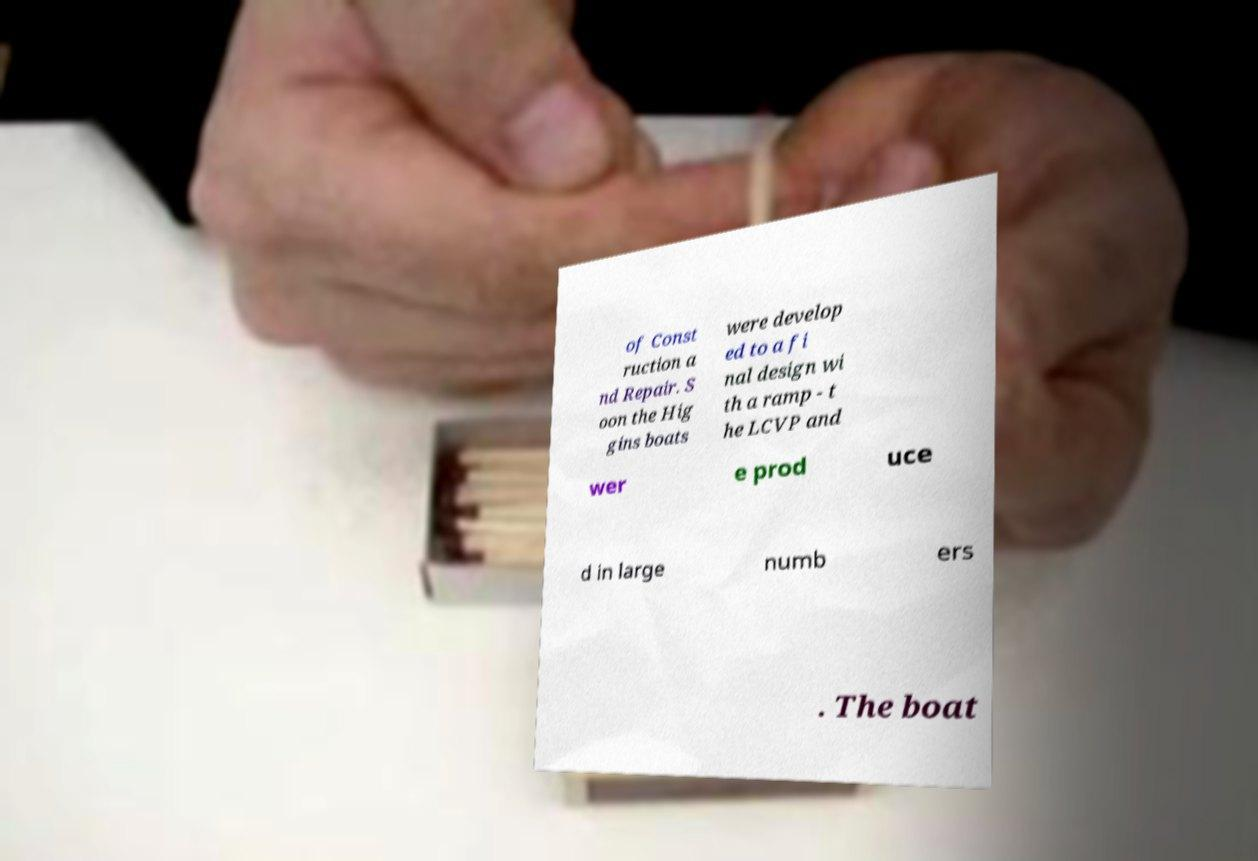What messages or text are displayed in this image? I need them in a readable, typed format. of Const ruction a nd Repair. S oon the Hig gins boats were develop ed to a fi nal design wi th a ramp - t he LCVP and wer e prod uce d in large numb ers . The boat 